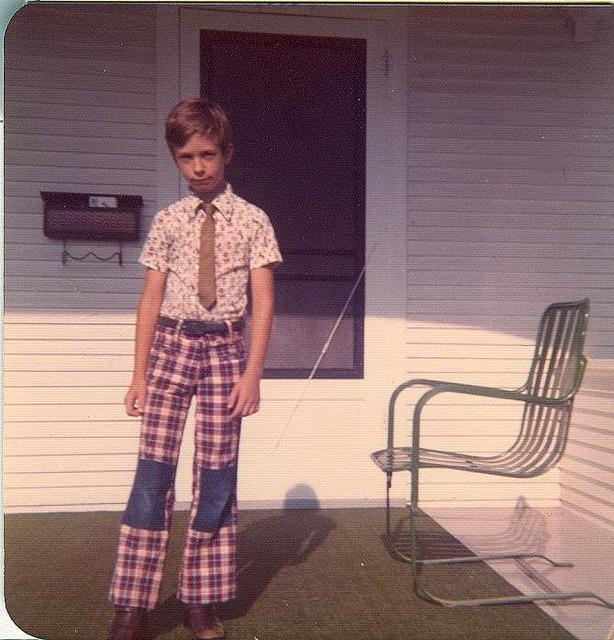How many chairs are visible?
Give a very brief answer. 1. 